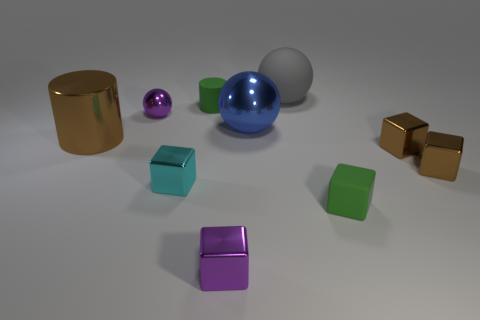Are there an equal number of tiny shiny cubes that are right of the rubber cylinder and purple spheres that are behind the small green cube?
Your answer should be very brief. No. How many other things are there of the same shape as the big matte thing?
Offer a very short reply. 2. Does the green rubber cube in front of the large gray rubber object have the same size as the shiny sphere behind the large metallic ball?
Keep it short and to the point. Yes. What number of cylinders are tiny matte objects or tiny cyan shiny objects?
Offer a very short reply. 1. How many shiny objects are either big blue spheres or tiny brown things?
Your answer should be compact. 3. What size is the other purple thing that is the same shape as the big matte object?
Provide a short and direct response. Small. Is the size of the gray sphere the same as the brown metallic thing on the left side of the purple shiny cube?
Make the answer very short. Yes. What is the shape of the small purple thing left of the green cylinder?
Your answer should be very brief. Sphere. What is the color of the metal cube in front of the matte object that is in front of the large cylinder?
Keep it short and to the point. Purple. What is the color of the other small matte thing that is the same shape as the cyan thing?
Offer a terse response. Green. 